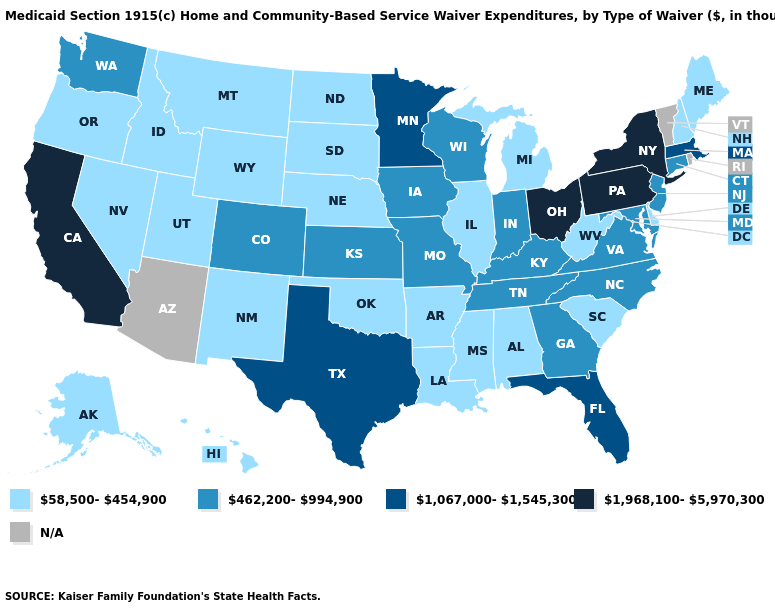What is the highest value in the South ?
Answer briefly. 1,067,000-1,545,300. Name the states that have a value in the range 1,968,100-5,970,300?
Concise answer only. California, New York, Ohio, Pennsylvania. What is the value of New Jersey?
Short answer required. 462,200-994,900. Name the states that have a value in the range 58,500-454,900?
Be succinct. Alabama, Alaska, Arkansas, Delaware, Hawaii, Idaho, Illinois, Louisiana, Maine, Michigan, Mississippi, Montana, Nebraska, Nevada, New Hampshire, New Mexico, North Dakota, Oklahoma, Oregon, South Carolina, South Dakota, Utah, West Virginia, Wyoming. Does Utah have the highest value in the West?
Give a very brief answer. No. Does the map have missing data?
Short answer required. Yes. Does Indiana have the highest value in the USA?
Quick response, please. No. Is the legend a continuous bar?
Keep it brief. No. Name the states that have a value in the range 1,067,000-1,545,300?
Give a very brief answer. Florida, Massachusetts, Minnesota, Texas. Does the map have missing data?
Concise answer only. Yes. What is the highest value in the USA?
Keep it brief. 1,968,100-5,970,300. What is the value of Indiana?
Short answer required. 462,200-994,900. Name the states that have a value in the range 1,067,000-1,545,300?
Concise answer only. Florida, Massachusetts, Minnesota, Texas. What is the value of Alaska?
Quick response, please. 58,500-454,900. 